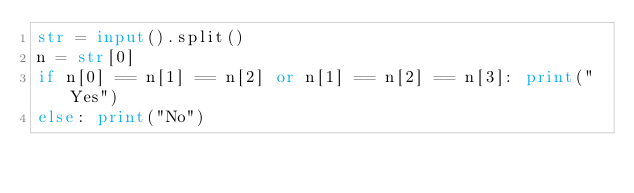<code> <loc_0><loc_0><loc_500><loc_500><_Python_>str = input().split()
n = str[0]
if n[0] == n[1] == n[2] or n[1] == n[2] == n[3]: print("Yes")
else: print("No")</code> 